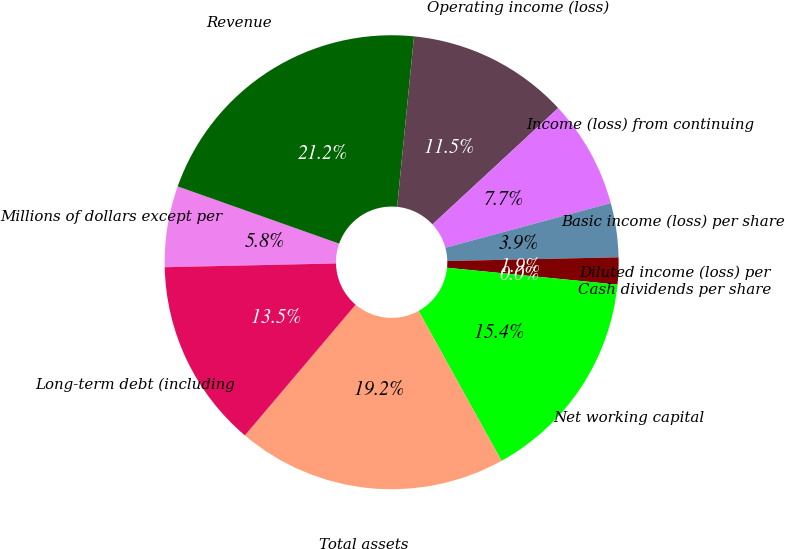Convert chart. <chart><loc_0><loc_0><loc_500><loc_500><pie_chart><fcel>Millions of dollars except per<fcel>Revenue<fcel>Operating income (loss)<fcel>Income (loss) from continuing<fcel>Basic income (loss) per share<fcel>Diluted income (loss) per<fcel>Cash dividends per share<fcel>Net working capital<fcel>Total assets<fcel>Long-term debt (including<nl><fcel>5.77%<fcel>21.15%<fcel>11.54%<fcel>7.69%<fcel>3.85%<fcel>1.92%<fcel>0.0%<fcel>15.38%<fcel>19.23%<fcel>13.46%<nl></chart> 